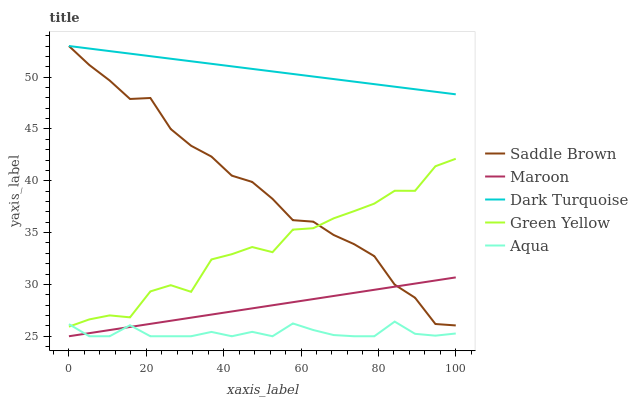Does Aqua have the minimum area under the curve?
Answer yes or no. Yes. Does Dark Turquoise have the maximum area under the curve?
Answer yes or no. Yes. Does Green Yellow have the minimum area under the curve?
Answer yes or no. No. Does Green Yellow have the maximum area under the curve?
Answer yes or no. No. Is Maroon the smoothest?
Answer yes or no. Yes. Is Green Yellow the roughest?
Answer yes or no. Yes. Is Aqua the smoothest?
Answer yes or no. No. Is Aqua the roughest?
Answer yes or no. No. Does Aqua have the lowest value?
Answer yes or no. Yes. Does Green Yellow have the lowest value?
Answer yes or no. No. Does Saddle Brown have the highest value?
Answer yes or no. Yes. Does Green Yellow have the highest value?
Answer yes or no. No. Is Maroon less than Dark Turquoise?
Answer yes or no. Yes. Is Saddle Brown greater than Aqua?
Answer yes or no. Yes. Does Dark Turquoise intersect Saddle Brown?
Answer yes or no. Yes. Is Dark Turquoise less than Saddle Brown?
Answer yes or no. No. Is Dark Turquoise greater than Saddle Brown?
Answer yes or no. No. Does Maroon intersect Dark Turquoise?
Answer yes or no. No. 